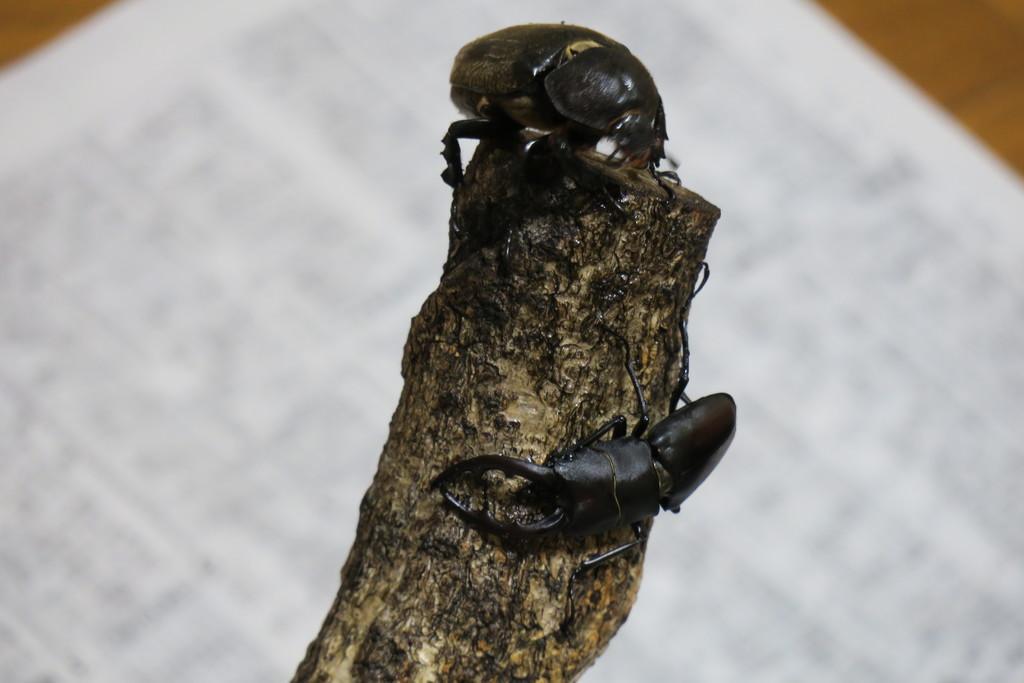Describe this image in one or two sentences. In this image I can see a wooden log and two insects which are black in color on the wooden log. In the background I can see brown and white colored objects. 